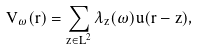<formula> <loc_0><loc_0><loc_500><loc_500>V _ { \omega } ( { r } ) = \sum _ { { z } \in { L } ^ { 2 } } \lambda _ { z } ( \omega ) u ( { r } - { z } ) ,</formula> 